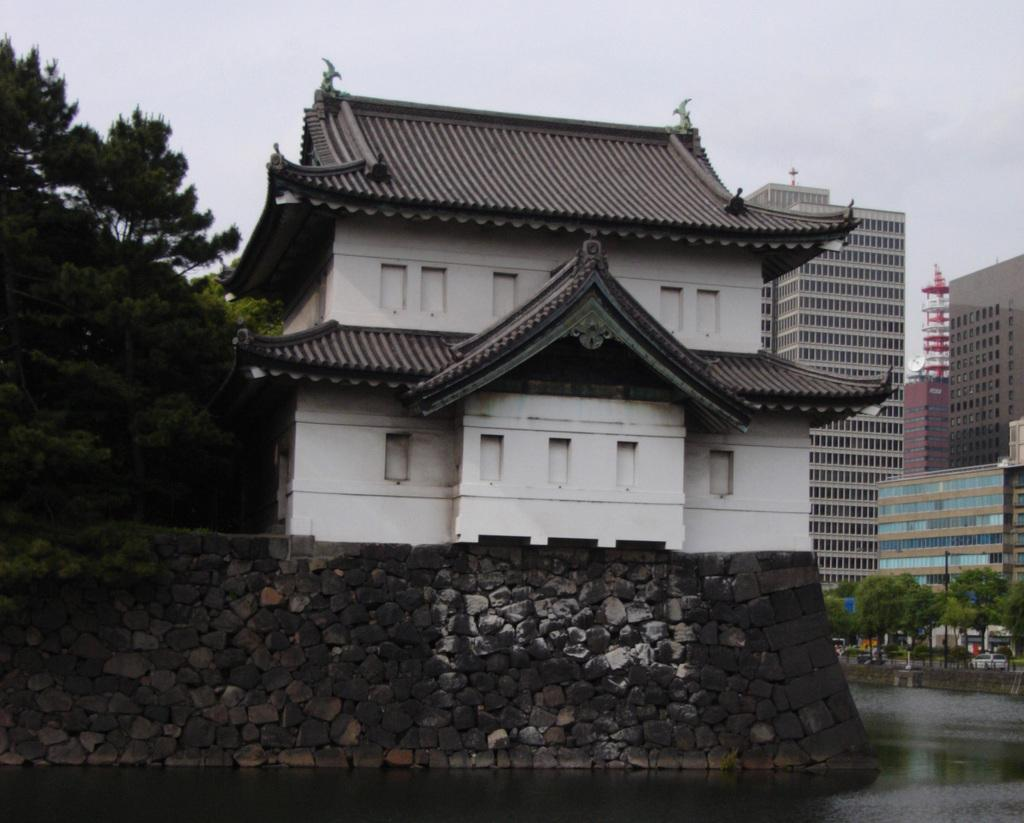What is the main feature in the center of the image? There is a lake in the middle of the image. What structures can be seen on either side of the lake? There are buildings on either side of the lake. What type of vegetation is present near the buildings? Trees arees are present beside the buildings. What type of poison is being used by the trees in the image? There is no mention of poison in the image; the trees are not using any poison. 